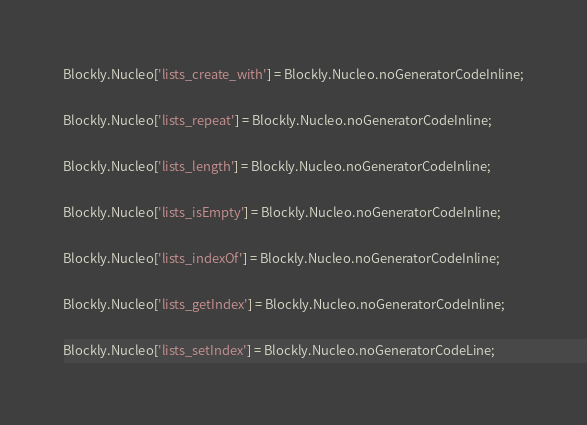Convert code to text. <code><loc_0><loc_0><loc_500><loc_500><_JavaScript_>Blockly.Nucleo['lists_create_with'] = Blockly.Nucleo.noGeneratorCodeInline;

Blockly.Nucleo['lists_repeat'] = Blockly.Nucleo.noGeneratorCodeInline;

Blockly.Nucleo['lists_length'] = Blockly.Nucleo.noGeneratorCodeInline;

Blockly.Nucleo['lists_isEmpty'] = Blockly.Nucleo.noGeneratorCodeInline;

Blockly.Nucleo['lists_indexOf'] = Blockly.Nucleo.noGeneratorCodeInline;

Blockly.Nucleo['lists_getIndex'] = Blockly.Nucleo.noGeneratorCodeInline;

Blockly.Nucleo['lists_setIndex'] = Blockly.Nucleo.noGeneratorCodeLine;
</code> 